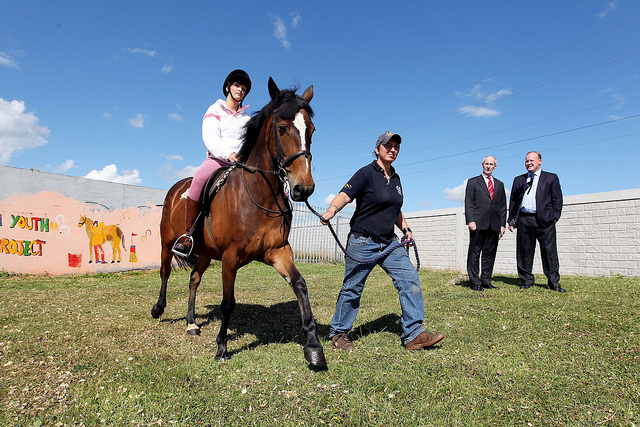Read and extract the text from this image. YOUTH ROJECT 